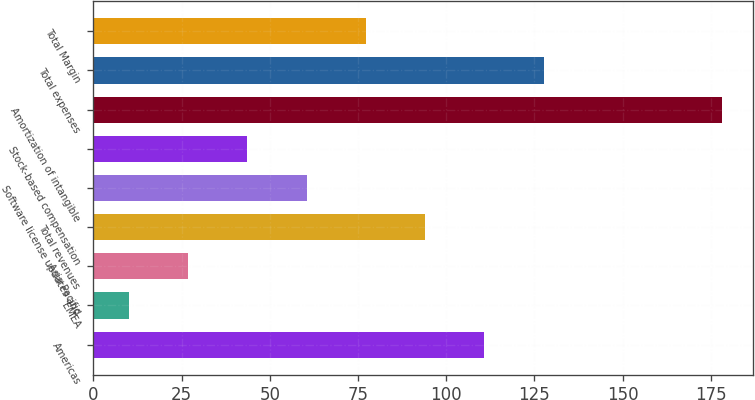Convert chart. <chart><loc_0><loc_0><loc_500><loc_500><bar_chart><fcel>Americas<fcel>EMEA<fcel>Asia Pacific<fcel>Total revenues<fcel>Software license updates and<fcel>Stock-based compensation<fcel>Amortization of intangible<fcel>Total expenses<fcel>Total Margin<nl><fcel>110.8<fcel>10<fcel>26.8<fcel>94<fcel>60.4<fcel>43.6<fcel>178<fcel>127.6<fcel>77.2<nl></chart> 